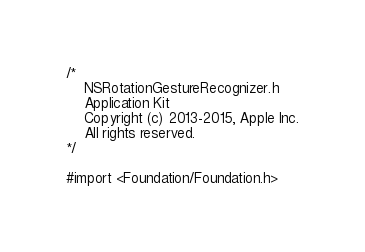<code> <loc_0><loc_0><loc_500><loc_500><_C_>/*
    NSRotationGestureRecognizer.h
    Application Kit
    Copyright (c) 2013-2015, Apple Inc.
    All rights reserved.
*/

#import <Foundation/Foundation.h></code> 